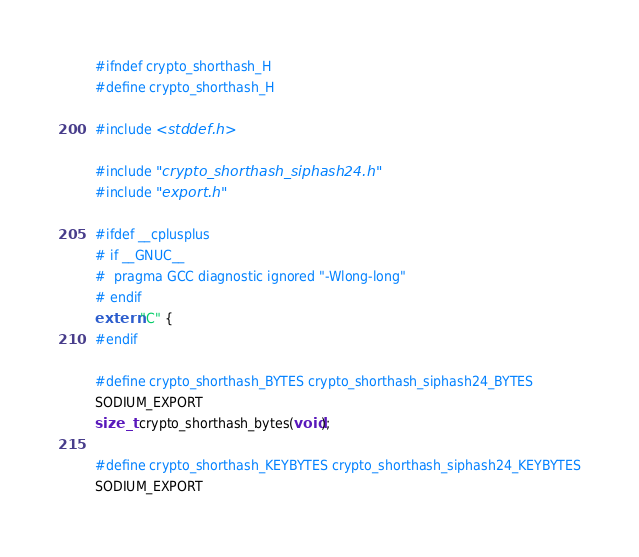Convert code to text. <code><loc_0><loc_0><loc_500><loc_500><_C_>#ifndef crypto_shorthash_H
#define crypto_shorthash_H

#include <stddef.h>

#include "crypto_shorthash_siphash24.h"
#include "export.h"

#ifdef __cplusplus
# if __GNUC__
#  pragma GCC diagnostic ignored "-Wlong-long"
# endif
extern "C" {
#endif

#define crypto_shorthash_BYTES crypto_shorthash_siphash24_BYTES
SODIUM_EXPORT
size_t  crypto_shorthash_bytes(void);

#define crypto_shorthash_KEYBYTES crypto_shorthash_siphash24_KEYBYTES
SODIUM_EXPORT</code> 